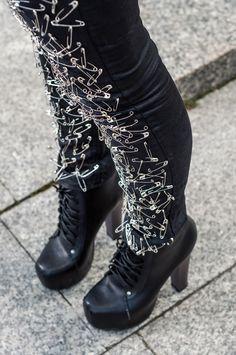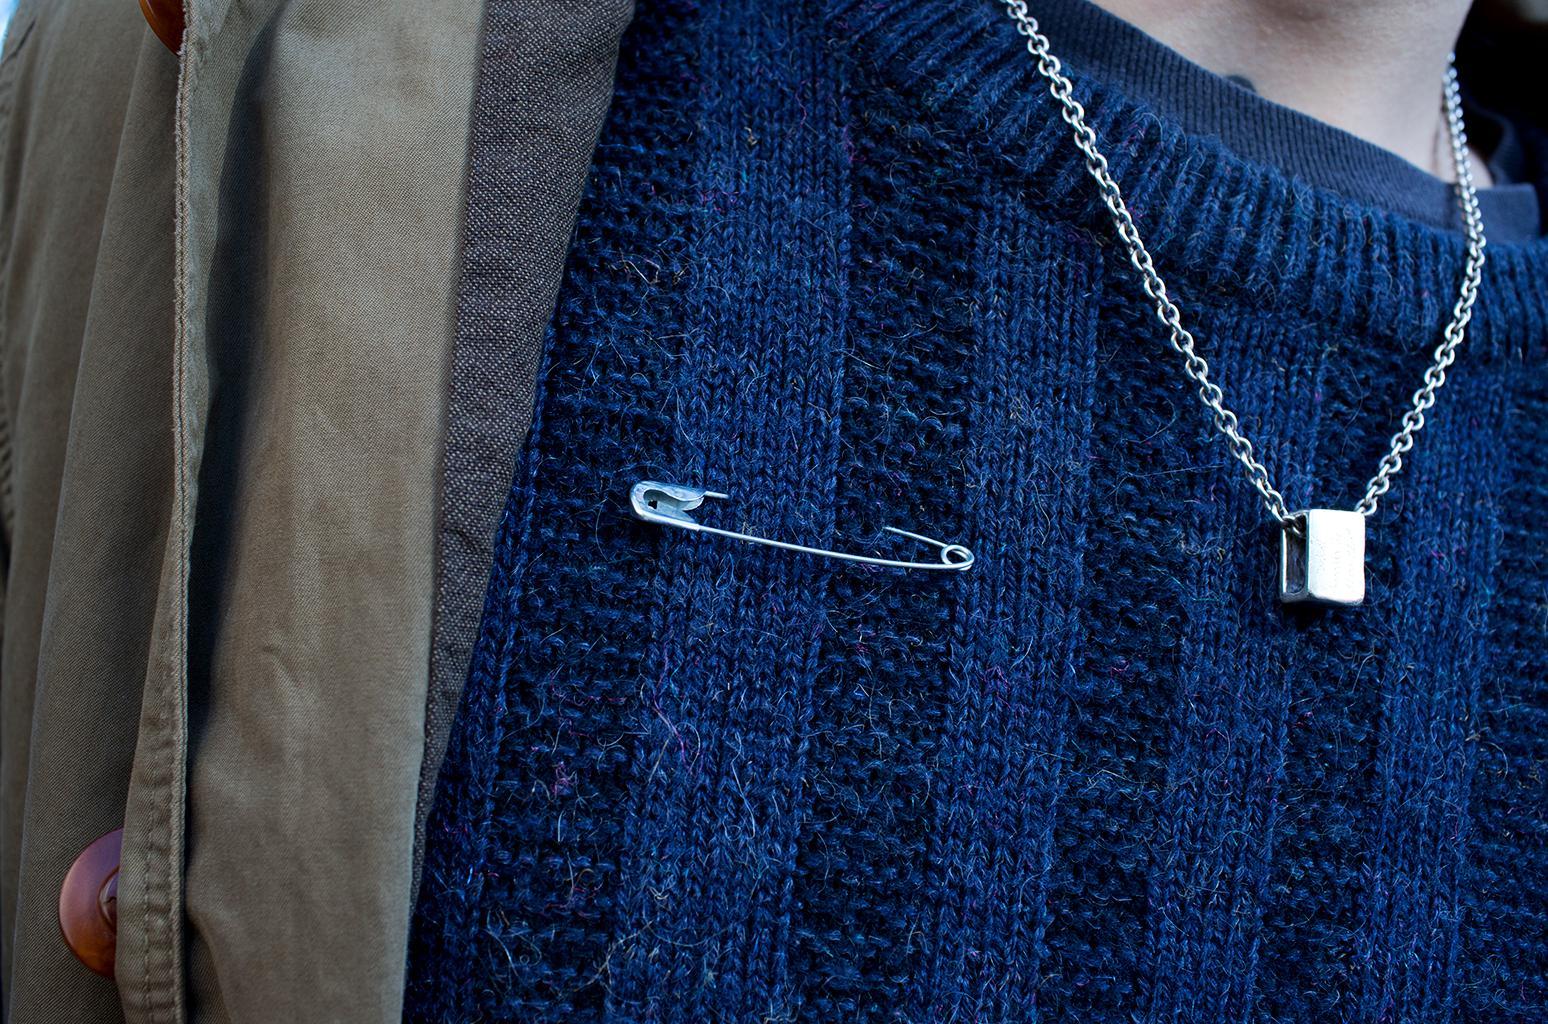The first image is the image on the left, the second image is the image on the right. For the images shown, is this caption "someone is wearing a pair of pants full of safety pins and a pair of heels" true? Answer yes or no. Yes. The first image is the image on the left, the second image is the image on the right. Evaluate the accuracy of this statement regarding the images: "One of the images shows high heeled platform shoes.". Is it true? Answer yes or no. Yes. 